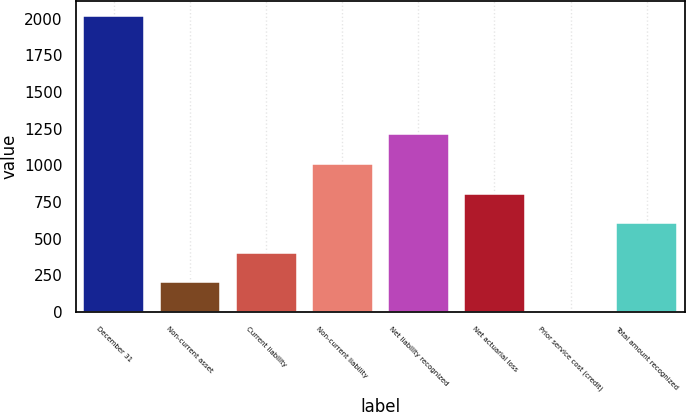<chart> <loc_0><loc_0><loc_500><loc_500><bar_chart><fcel>December 31<fcel>Non-current asset<fcel>Current liability<fcel>Non-current liability<fcel>Net liability recognized<fcel>Net actuarial loss<fcel>Prior service cost (credit)<fcel>Total amount recognized<nl><fcel>2017<fcel>202.06<fcel>403.72<fcel>1008.7<fcel>1210.36<fcel>807.04<fcel>0.4<fcel>605.38<nl></chart> 